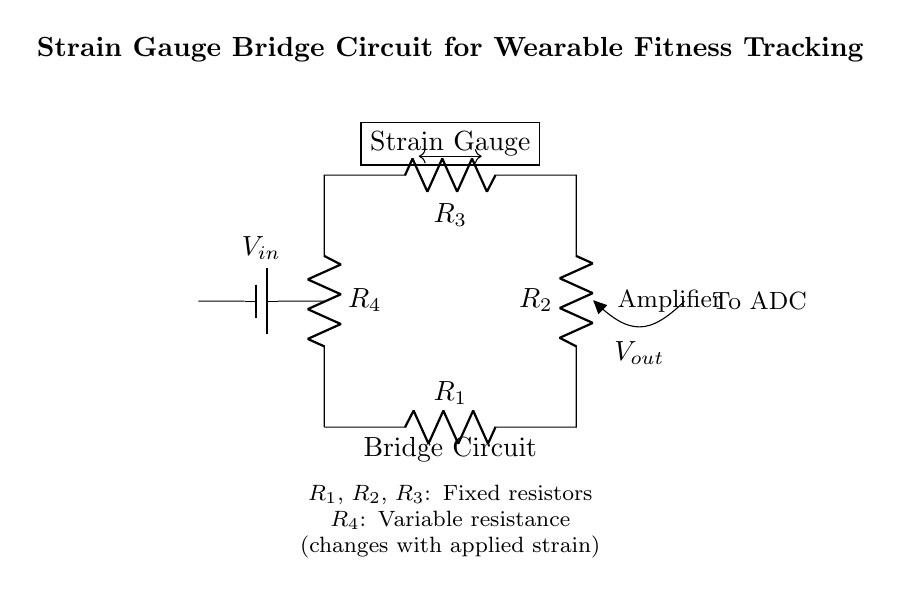What type of circuit is displayed? The circuit is a bridge circuit, specifically a strain gauge bridge circuit which is often used in applications like measuring strain or pressure.
Answer: Bridge circuit How many resistors are in the circuit? The circuit shows a total of four resistors: three fixed resistors (R1, R2, R3) and one variable resistor (R4).
Answer: Four resistors What does R4 represent in the circuit? R4 is a variable resistor whose resistance changes with the applied strain on the strain gauge. This adjusts the balance of the bridge circuit based on strain.
Answer: Variable resistance What is the purpose of the strain gauge in the circuit? The strain gauge's purpose is to detect strain, which changes the resistance of R4 and ultimately affects the output voltage across the bridge.
Answer: Detects strain What is the output voltage labeled as? The output voltage is labeled as Vout in the circuit diagram, indicating the voltage difference at the output of the bridge.
Answer: Vout How does applying strain affect the circuit? Applying strain changes the resistance of R4, which unbalances the bridge circuit, leading to a change in the output voltage Vout proportional to the strain applied.
Answer: Changes Vout 